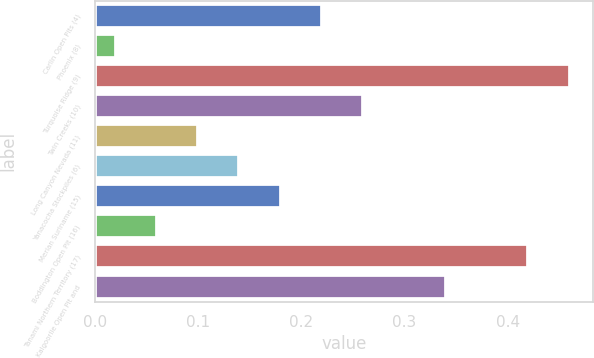Convert chart. <chart><loc_0><loc_0><loc_500><loc_500><bar_chart><fcel>Carlin Open Pits (4)<fcel>Phoenix (8)<fcel>Turquoise Ridge (9)<fcel>Twin Creeks (10)<fcel>Long Canyon Nevada (11)<fcel>Yanacocha Stockpiles (6)<fcel>Merian Suriname (15)<fcel>Boddington Open Pit (16)<fcel>Tanami Northern Territory (17)<fcel>Kalgoorlie Open Pit and<nl><fcel>0.22<fcel>0.02<fcel>0.46<fcel>0.26<fcel>0.1<fcel>0.14<fcel>0.18<fcel>0.06<fcel>0.42<fcel>0.34<nl></chart> 